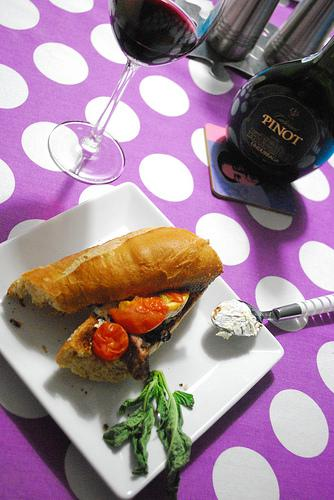Question: what is being served?
Choices:
A. Pizza.
B. A sandwich.
C. Beer.
D. Chicken Wings.
Answer with the letter. Answer: B Question: what color is the tablecloth?
Choices:
A. Purple with white polka dots.
B. Black.
C. Green.
D. Blue.
Answer with the letter. Answer: A Question: what type of wine is this?
Choices:
A. Chardonnay.
B. White Zinfandel.
C. Merlot.
D. Pinot.
Answer with the letter. Answer: D Question: where is this scene?
Choices:
A. In a restaurant.
B. In a movie theater.
C. At the beach.
D. At the party.
Answer with the letter. Answer: A Question: why is there a spoon?
Choices:
A. To eat with.
B. To use as a weapon.
C. To apply a condiment.
D. To be washed.
Answer with the letter. Answer: C 